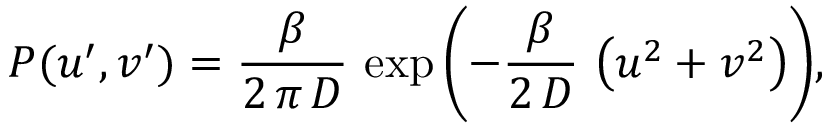<formula> <loc_0><loc_0><loc_500><loc_500>P ( u ^ { \prime } , v ^ { \prime } ) = \frac { \beta } { 2 \, \pi \, D } \, \exp { \left ( - \frac { \beta } { 2 \, D } \, \left ( u ^ { 2 } + v ^ { 2 } \right ) \right ) } ,</formula> 